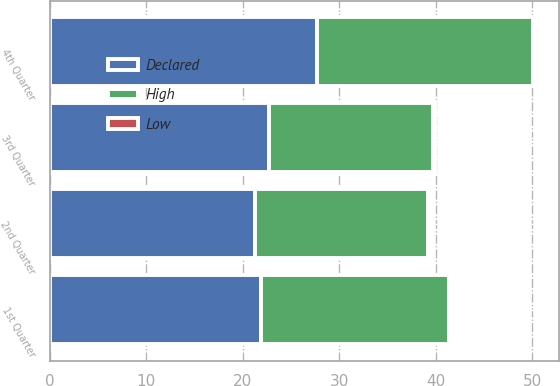<chart> <loc_0><loc_0><loc_500><loc_500><stacked_bar_chart><ecel><fcel>1st Quarter<fcel>2nd Quarter<fcel>3rd Quarter<fcel>4th Quarter<nl><fcel>Declared<fcel>21.9<fcel>21.27<fcel>22.75<fcel>27.69<nl><fcel>High<fcel>19.52<fcel>17.9<fcel>17<fcel>22.41<nl><fcel>Low<fcel>0.12<fcel>0.12<fcel>0.12<fcel>0.12<nl></chart> 